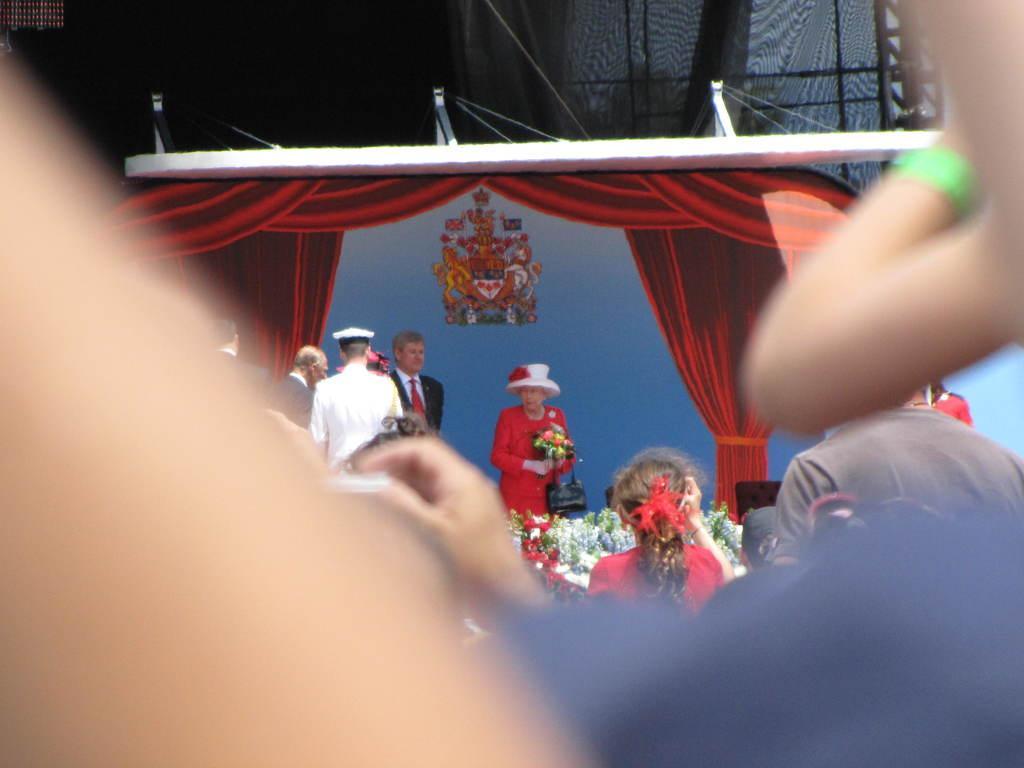How would you summarize this image in a sentence or two? In this image we can see curtains, plants, people and chair. One woman is holding a bouquet. Backside there is a sticker. 